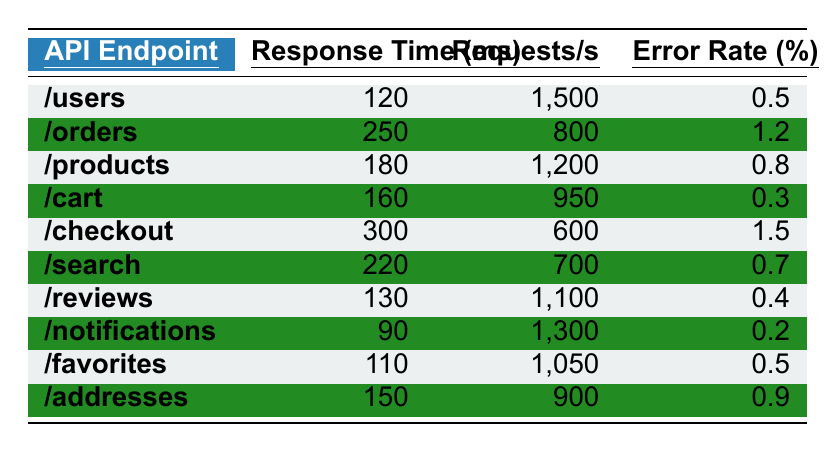What is the response time for the "/products" API endpoint? By checking the "/products" row in the table, the response time is noted as 180 milliseconds.
Answer: 180 ms Which API endpoint has the highest error rate? I look through the error rates in each row. The "/checkout" endpoint has an error rate of 1.5%, which is the highest among all listed endpoints.
Answer: /checkout What is the average response time of all API endpoints? I sum the response times: (120 + 250 + 180 + 160 + 300 + 220 + 130 + 90 + 110 + 150) = 1,770 ms. There are 10 endpoints, so the average is 1,770 ms / 10 = 177 ms.
Answer: 177 ms Which API endpoints have a response time greater than 200 ms? I check each response time in the table and find that "/orders" (250 ms) and "/checkout" (300 ms) are the only endpoints with response times exceeding 200 ms.
Answer: /orders, /checkout Is the error rate for the "/notifications" API endpoint less than 1%? I check the error rate for "/notifications," which is 0.2%. Since 0.2% is less than 1%, the answer is yes.
Answer: Yes What is the total number of requests per second across all API endpoints? I sum the requests per second: (1500 + 800 + 1200 + 950 + 600 + 700 + 1100 + 1300 + 1050 + 900) = 8050 requests per second total.
Answer: 8050 requests/s How does the response time of the "/cart" API endpoint compare to that of the "/favorites" endpoint? I compare "/cart" (160 ms) and "/favorites" (110 ms); "/cart" has a longer response time than "/favorites".
Answer: /cart is longer Which API endpoint has the second highest number of requests per second? I arrange the requests per second from highest to lowest: 1500, 1200, 1100, 950, 900, 800, 700, 600, 1300, 1050. The second highest is 1200 for the "/products" endpoint.
Answer: /products Are there more than three API endpoints with an error rate greater than 0.5%? I check the error rates again and count: "/orders" (1.2%), "/checkout" (1.5%), and "/addresses" (0.9%) giving us three endpoints above 0.5% only, so the statement is false.
Answer: No What is the difference in response time between the fastest and slowest API endpoints? The fastest is "/notifications" (90 ms) and the slowest is "/checkout" (300 ms). The difference is 300 - 90 = 210 ms.
Answer: 210 ms 